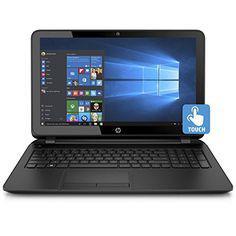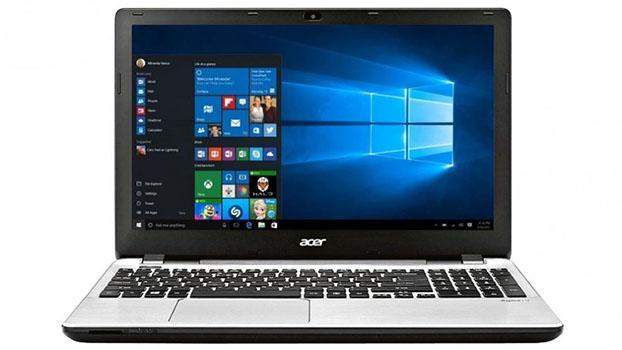The first image is the image on the left, the second image is the image on the right. For the images shown, is this caption "The laptop on the right has its start menu open and visible." true? Answer yes or no. Yes. The first image is the image on the left, the second image is the image on the right. Examine the images to the left and right. Is the description "At least one laptop shows the Windows menu." accurate? Answer yes or no. Yes. 